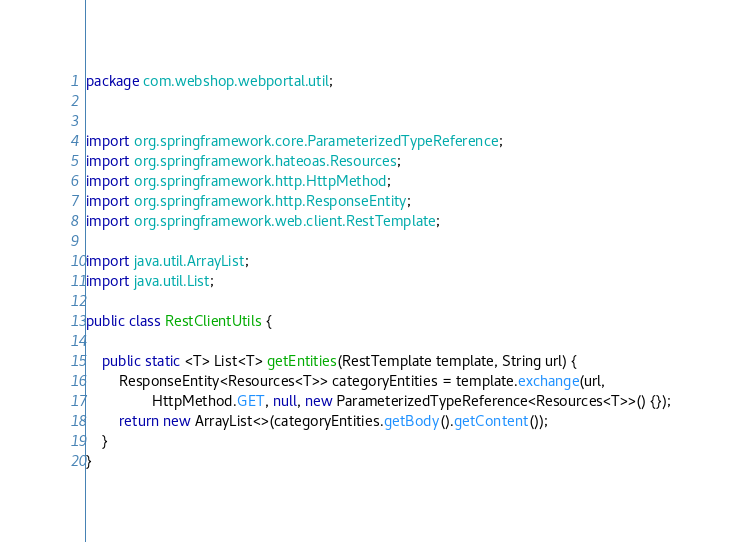Convert code to text. <code><loc_0><loc_0><loc_500><loc_500><_Java_>package com.webshop.webportal.util;


import org.springframework.core.ParameterizedTypeReference;
import org.springframework.hateoas.Resources;
import org.springframework.http.HttpMethod;
import org.springframework.http.ResponseEntity;
import org.springframework.web.client.RestTemplate;

import java.util.ArrayList;
import java.util.List;

public class RestClientUtils {

    public static <T> List<T> getEntities(RestTemplate template, String url) {
        ResponseEntity<Resources<T>> categoryEntities = template.exchange(url,
                HttpMethod.GET, null, new ParameterizedTypeReference<Resources<T>>() {});
        return new ArrayList<>(categoryEntities.getBody().getContent());
    }
}
</code> 